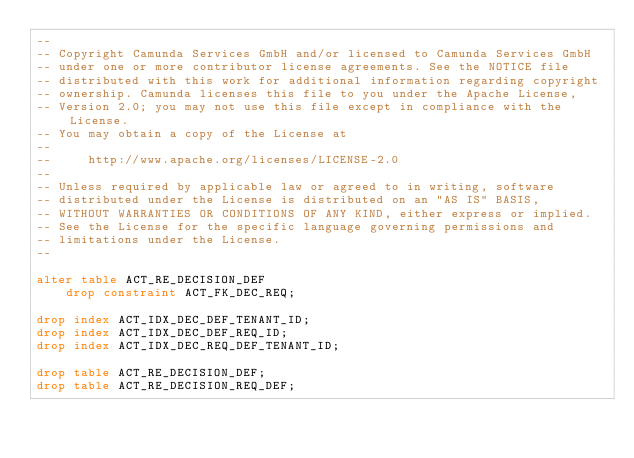Convert code to text. <code><loc_0><loc_0><loc_500><loc_500><_SQL_>--
-- Copyright Camunda Services GmbH and/or licensed to Camunda Services GmbH
-- under one or more contributor license agreements. See the NOTICE file
-- distributed with this work for additional information regarding copyright
-- ownership. Camunda licenses this file to you under the Apache License,
-- Version 2.0; you may not use this file except in compliance with the License.
-- You may obtain a copy of the License at
--
--     http://www.apache.org/licenses/LICENSE-2.0
--
-- Unless required by applicable law or agreed to in writing, software
-- distributed under the License is distributed on an "AS IS" BASIS,
-- WITHOUT WARRANTIES OR CONDITIONS OF ANY KIND, either express or implied.
-- See the License for the specific language governing permissions and
-- limitations under the License.
--

alter table ACT_RE_DECISION_DEF
    drop constraint ACT_FK_DEC_REQ;

drop index ACT_IDX_DEC_DEF_TENANT_ID;
drop index ACT_IDX_DEC_DEF_REQ_ID;
drop index ACT_IDX_DEC_REQ_DEF_TENANT_ID;

drop table ACT_RE_DECISION_DEF;
drop table ACT_RE_DECISION_REQ_DEF;

</code> 